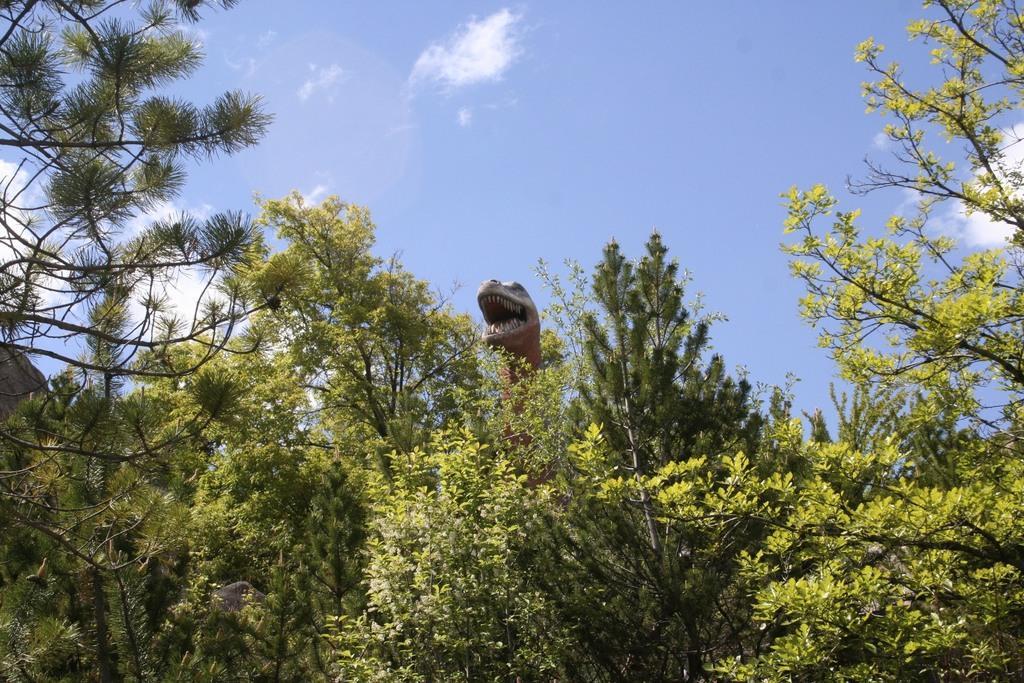Could you give a brief overview of what you see in this image? In the center of the image there is a dinosaur. There are many trees. 